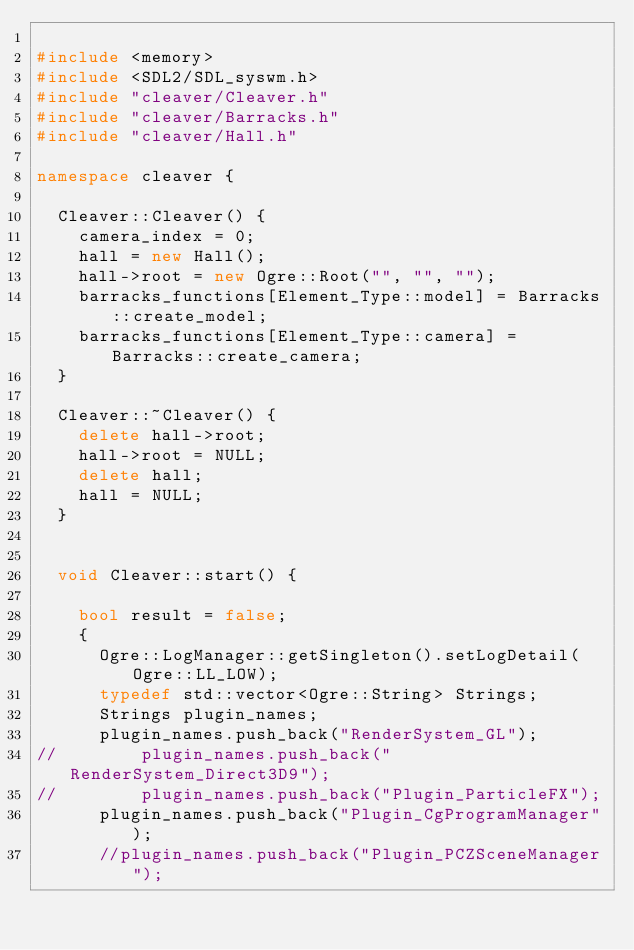<code> <loc_0><loc_0><loc_500><loc_500><_C++_>
#include <memory>
#include <SDL2/SDL_syswm.h>
#include "cleaver/Cleaver.h"
#include "cleaver/Barracks.h"
#include "cleaver/Hall.h"

namespace cleaver {

  Cleaver::Cleaver() {
    camera_index = 0;
    hall = new Hall();
    hall->root = new Ogre::Root("", "", "");
    barracks_functions[Element_Type::model] = Barracks::create_model;
    barracks_functions[Element_Type::camera] = Barracks::create_camera;
  }

  Cleaver::~Cleaver() {
    delete hall->root;
    hall->root = NULL;
    delete hall;
    hall = NULL;
  }


  void Cleaver::start() {

    bool result = false;
    {
      Ogre::LogManager::getSingleton().setLogDetail(Ogre::LL_LOW);
      typedef std::vector<Ogre::String> Strings;
      Strings plugin_names;
      plugin_names.push_back("RenderSystem_GL");
//        plugin_names.push_back("RenderSystem_Direct3D9");
//        plugin_names.push_back("Plugin_ParticleFX");
      plugin_names.push_back("Plugin_CgProgramManager");
      //plugin_names.push_back("Plugin_PCZSceneManager");</code> 